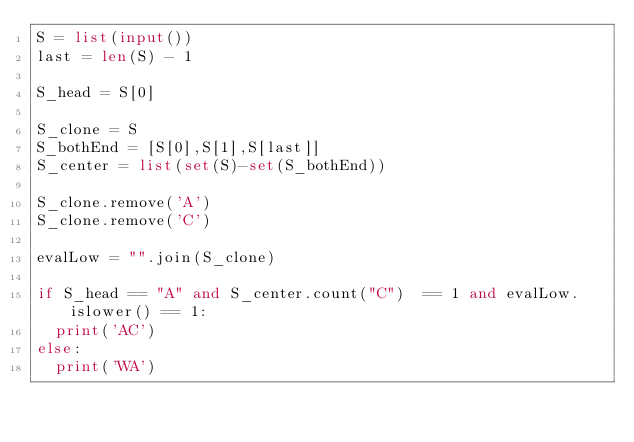<code> <loc_0><loc_0><loc_500><loc_500><_Python_>S = list(input())
last = len(S) - 1

S_head = S[0]

S_clone = S
S_bothEnd = [S[0],S[1],S[last]]
S_center = list(set(S)-set(S_bothEnd))

S_clone.remove('A')
S_clone.remove('C')

evalLow = "".join(S_clone)

if S_head == "A" and S_center.count("C")  == 1 and evalLow.islower() == 1:
  print('AC')
else:
  print('WA')</code> 